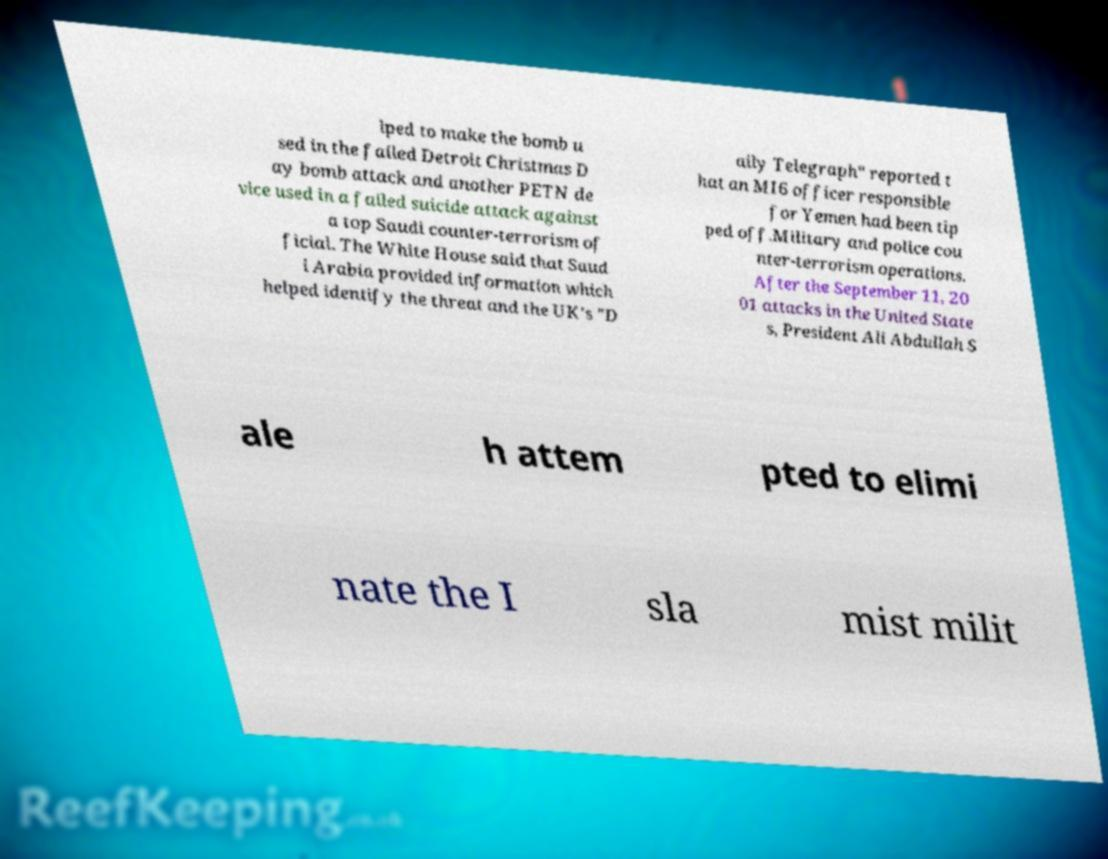I need the written content from this picture converted into text. Can you do that? lped to make the bomb u sed in the failed Detroit Christmas D ay bomb attack and another PETN de vice used in a failed suicide attack against a top Saudi counter-terrorism of ficial. The White House said that Saud i Arabia provided information which helped identify the threat and the UK's "D aily Telegraph" reported t hat an MI6 officer responsible for Yemen had been tip ped off.Military and police cou nter-terrorism operations. After the September 11, 20 01 attacks in the United State s, President Ali Abdullah S ale h attem pted to elimi nate the I sla mist milit 